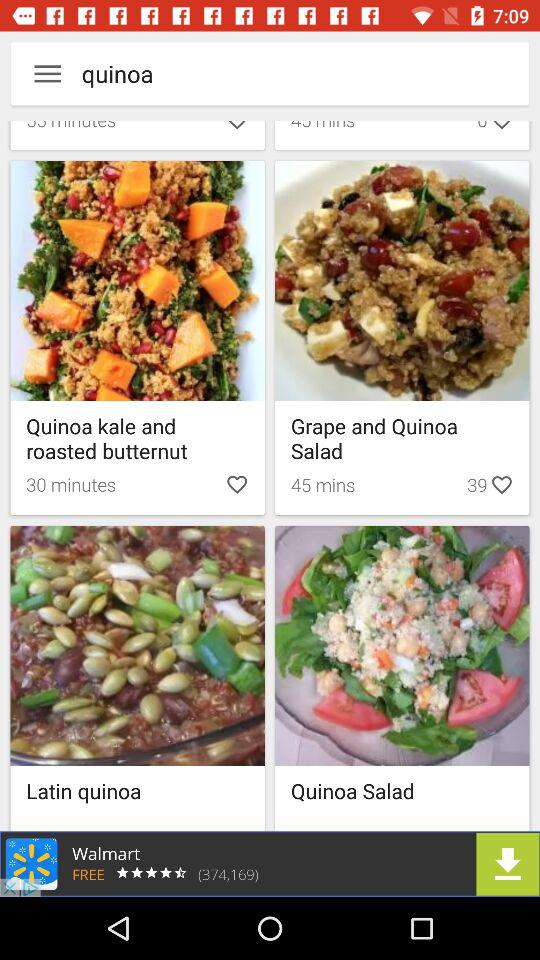How much time is required to prepare "Quinoa kale and roasted butternut"? The time required to prepare "Quinoa kale and roasted butternut" is 30 minutes. 